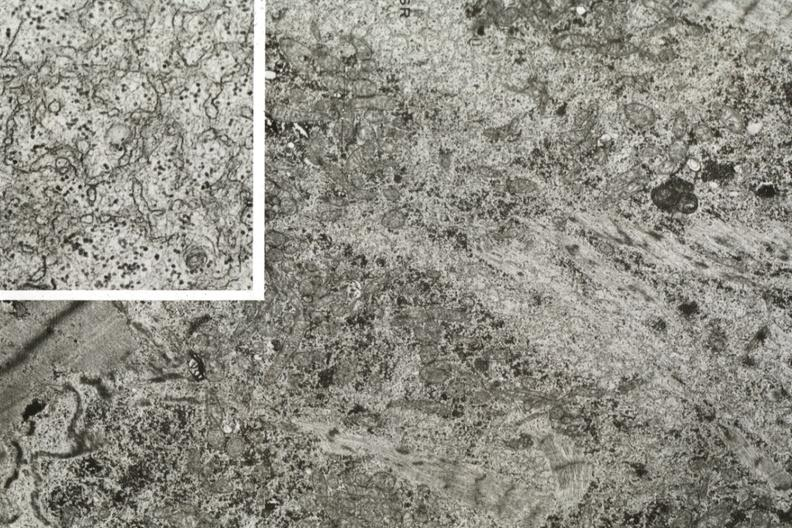s atrophy present?
Answer the question using a single word or phrase. Yes 